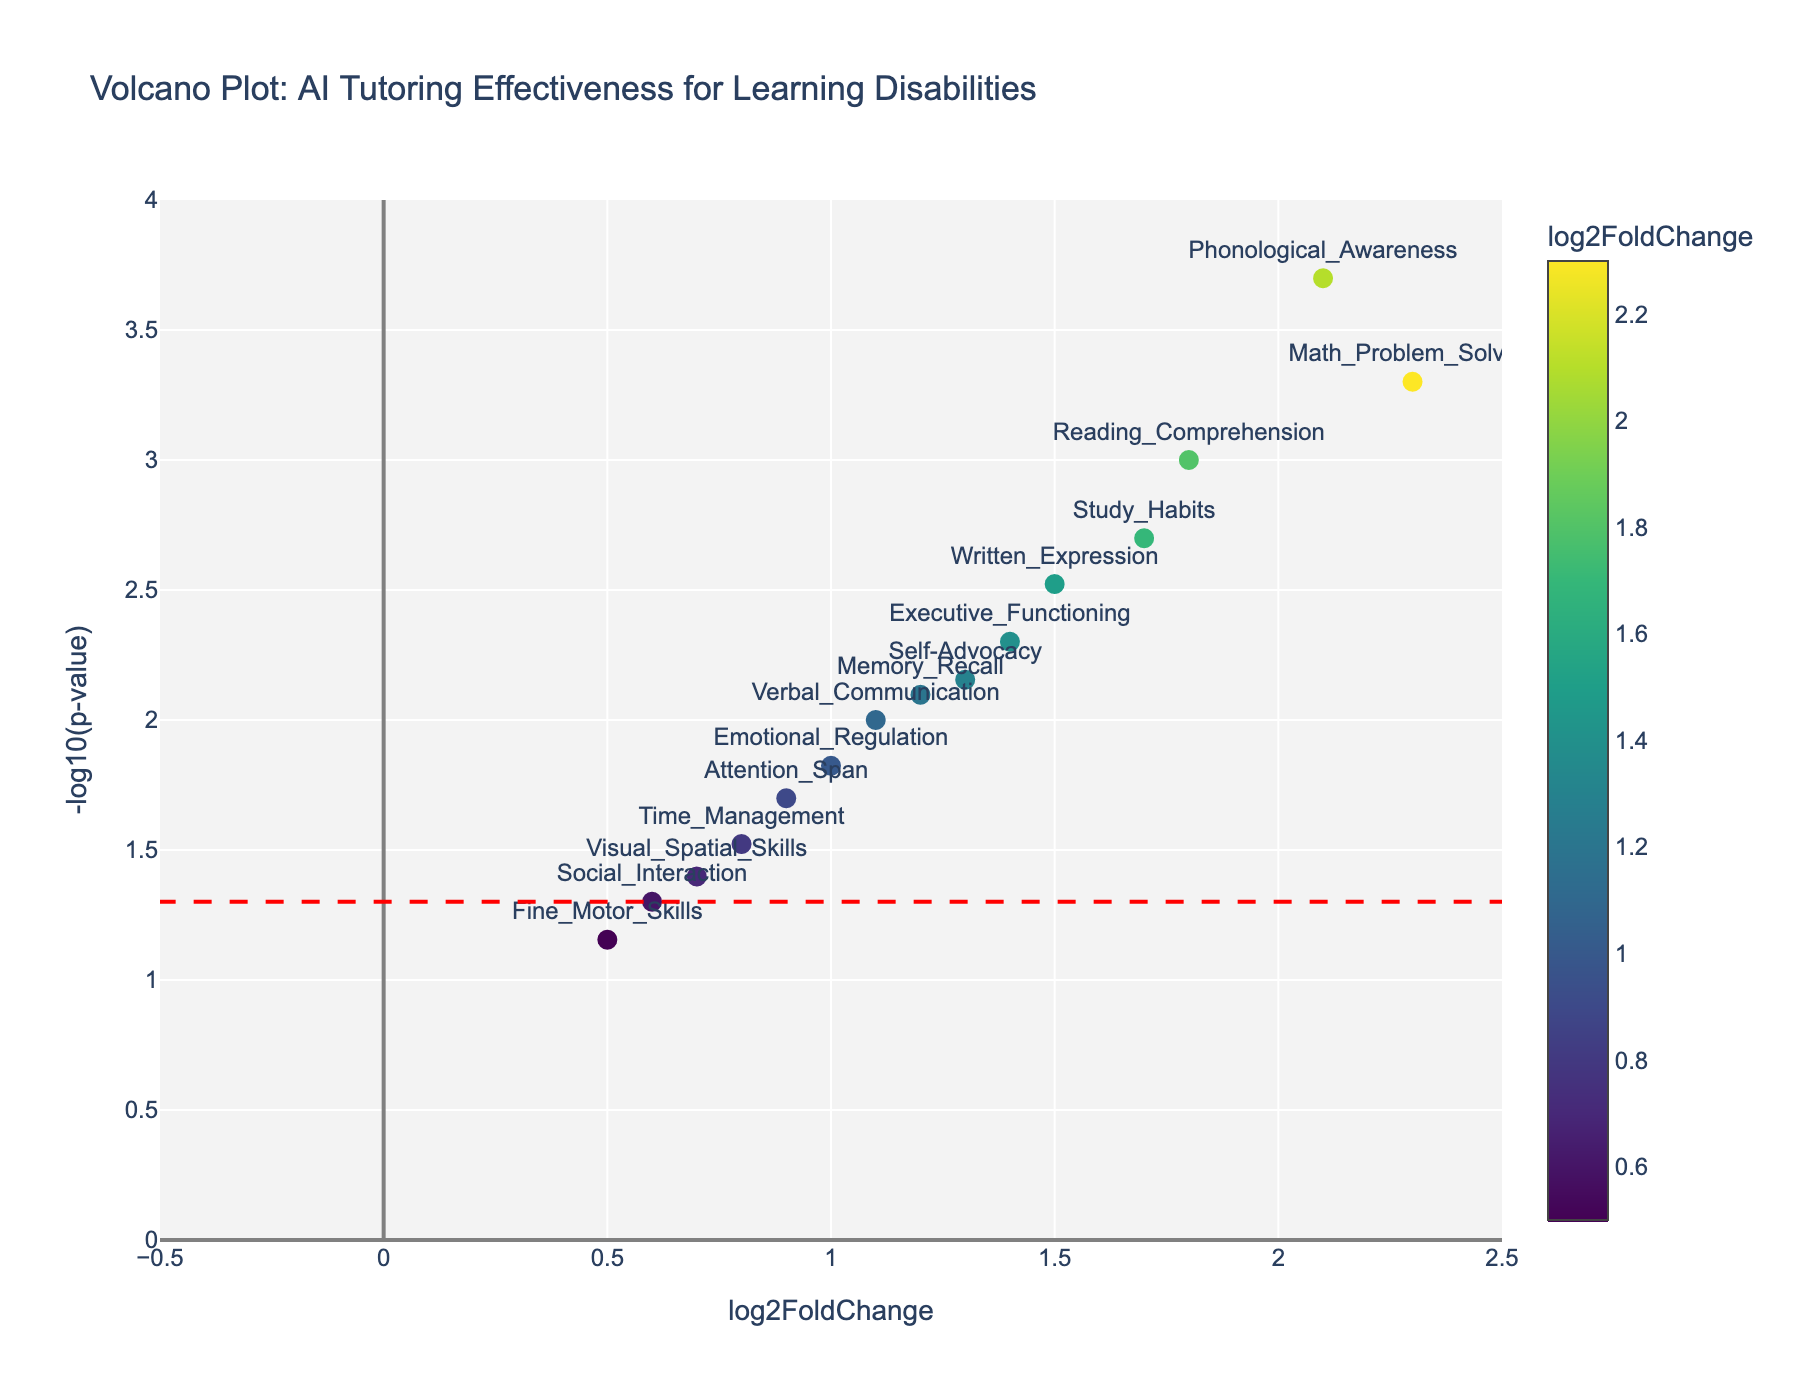What's the title of the figure? The title is prominently displayed at the top of the plot. It provides context for what the plot is depicting. In this case, the title is "Volcano Plot: AI Tutoring Effectiveness for Learning Disabilities".
Answer: Volcano Plot: AI Tutoring Effectiveness for Learning Disabilities What are the axes labels on the plot? The axes labels are given to describe the variables on each axis. The x-axis is labeled 'log2FoldChange', while the y-axis is labeled '-log10(p-value)'.
Answer: log2FoldChange and -log10(p-value) What does the color bar represent? The color bar on the right side of the plot is used to indicate the range of 'log2FoldChange' values, which are the effect sizes of the personalized AI tutoring systems.
Answer: log2FoldChange How many skill areas show a log2FoldChange of greater than 2? To answer this, find the points with a log2FoldChange greater than 2 along the x-axis. There are two such points: 'Math_Problem_Solving' (2.3) and 'Phonological_Awareness' (2.1).
Answer: 2 Which skill has the smallest p-value, and what is it? To find the smallest p-value, look for the point with the highest -log10(p-value) on the y-axis. 'Phonological_Awareness' has the smallest p-value of 0.0002.
Answer: Phonological_Awareness, 0.0002 Which skill shows the least significant improvement? The least significant improvement corresponds to the point with the lowest -log10(p-value) value that is still on the plot. 'Fine_Motor_Skills' has the highest p-value at 0.07, showing the least significant improvement.
Answer: Fine_Motor_Skills Which skills have p-values less than 0.005? Identify the points above the horizontal line at -log10(0.005). These skills are 'Reading_Comprehension', 'Math_Problem_Solving', 'Written_Expression', 'Phonological_Awareness', and 'Study_Habits'.
Answer: Reading_Comprehension, Math_Problem_Solving, Written_Expression, Phonological_Awareness, Study_Habits Among the skills with p-values less than 0.005, which has the lowest log2FoldChange? Among the skills listed in the previous answer, find the one with the lowest log2FoldChange value. It is 'Written_Expression' with a log2FoldChange of 1.5.
Answer: Written_Expression What is the range of -log10(p-value) displayed on the plot? The y-axis range tells us the span of -log10(p-value) values shown. In this case, the range is from approximately 0 to 4.
Answer: 0 to 4 